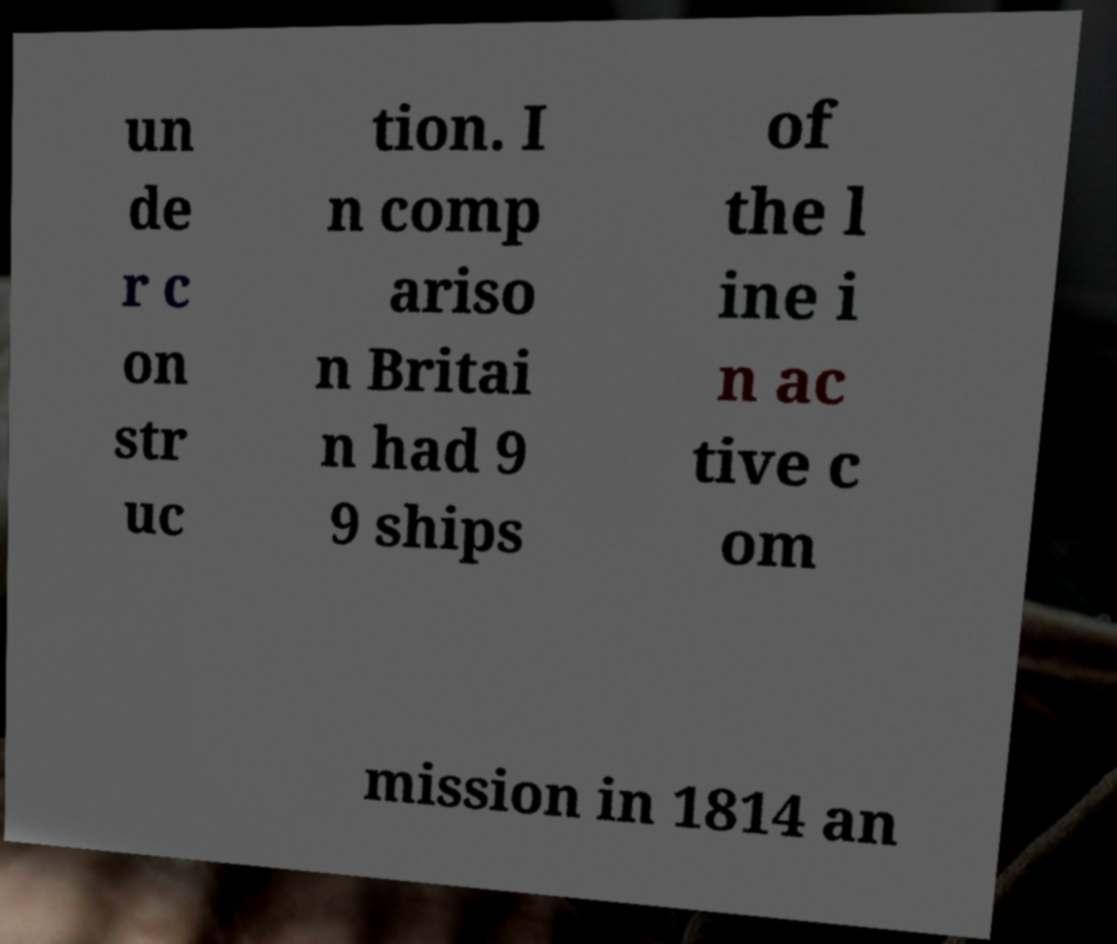Please identify and transcribe the text found in this image. un de r c on str uc tion. I n comp ariso n Britai n had 9 9 ships of the l ine i n ac tive c om mission in 1814 an 